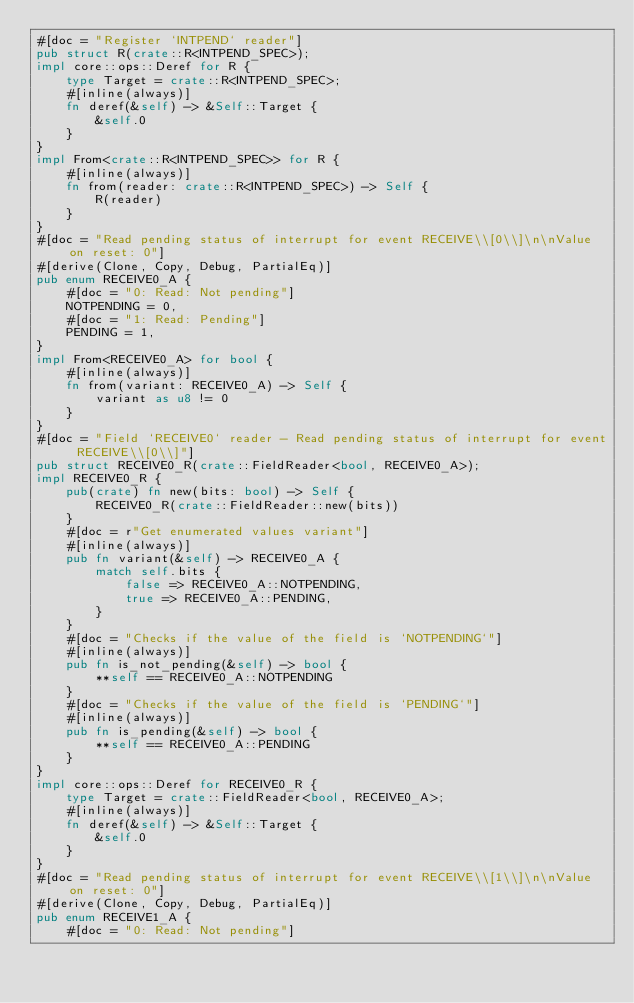Convert code to text. <code><loc_0><loc_0><loc_500><loc_500><_Rust_>#[doc = "Register `INTPEND` reader"]
pub struct R(crate::R<INTPEND_SPEC>);
impl core::ops::Deref for R {
    type Target = crate::R<INTPEND_SPEC>;
    #[inline(always)]
    fn deref(&self) -> &Self::Target {
        &self.0
    }
}
impl From<crate::R<INTPEND_SPEC>> for R {
    #[inline(always)]
    fn from(reader: crate::R<INTPEND_SPEC>) -> Self {
        R(reader)
    }
}
#[doc = "Read pending status of interrupt for event RECEIVE\\[0\\]\n\nValue on reset: 0"]
#[derive(Clone, Copy, Debug, PartialEq)]
pub enum RECEIVE0_A {
    #[doc = "0: Read: Not pending"]
    NOTPENDING = 0,
    #[doc = "1: Read: Pending"]
    PENDING = 1,
}
impl From<RECEIVE0_A> for bool {
    #[inline(always)]
    fn from(variant: RECEIVE0_A) -> Self {
        variant as u8 != 0
    }
}
#[doc = "Field `RECEIVE0` reader - Read pending status of interrupt for event RECEIVE\\[0\\]"]
pub struct RECEIVE0_R(crate::FieldReader<bool, RECEIVE0_A>);
impl RECEIVE0_R {
    pub(crate) fn new(bits: bool) -> Self {
        RECEIVE0_R(crate::FieldReader::new(bits))
    }
    #[doc = r"Get enumerated values variant"]
    #[inline(always)]
    pub fn variant(&self) -> RECEIVE0_A {
        match self.bits {
            false => RECEIVE0_A::NOTPENDING,
            true => RECEIVE0_A::PENDING,
        }
    }
    #[doc = "Checks if the value of the field is `NOTPENDING`"]
    #[inline(always)]
    pub fn is_not_pending(&self) -> bool {
        **self == RECEIVE0_A::NOTPENDING
    }
    #[doc = "Checks if the value of the field is `PENDING`"]
    #[inline(always)]
    pub fn is_pending(&self) -> bool {
        **self == RECEIVE0_A::PENDING
    }
}
impl core::ops::Deref for RECEIVE0_R {
    type Target = crate::FieldReader<bool, RECEIVE0_A>;
    #[inline(always)]
    fn deref(&self) -> &Self::Target {
        &self.0
    }
}
#[doc = "Read pending status of interrupt for event RECEIVE\\[1\\]\n\nValue on reset: 0"]
#[derive(Clone, Copy, Debug, PartialEq)]
pub enum RECEIVE1_A {
    #[doc = "0: Read: Not pending"]</code> 